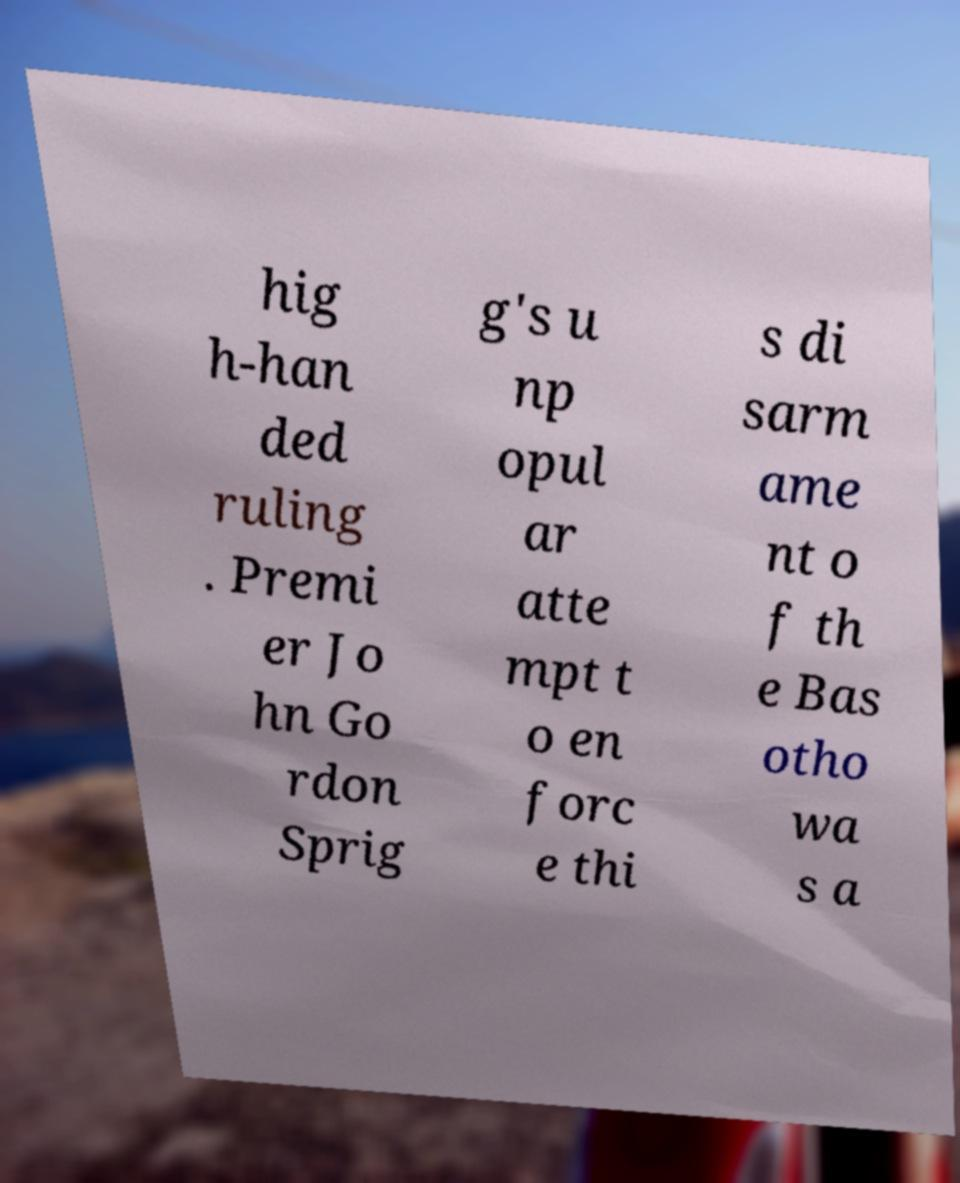Could you assist in decoding the text presented in this image and type it out clearly? hig h-han ded ruling . Premi er Jo hn Go rdon Sprig g's u np opul ar atte mpt t o en forc e thi s di sarm ame nt o f th e Bas otho wa s a 